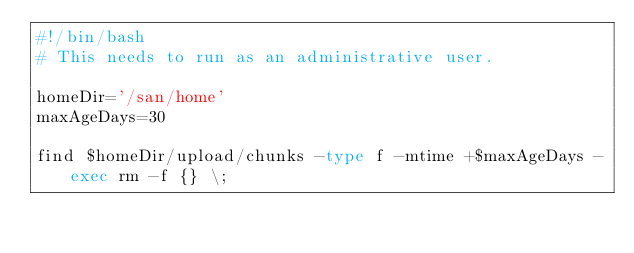Convert code to text. <code><loc_0><loc_0><loc_500><loc_500><_Bash_>#!/bin/bash
# This needs to run as an administrative user.

homeDir='/san/home'
maxAgeDays=30

find $homeDir/upload/chunks -type f -mtime +$maxAgeDays -exec rm -f {} \;
</code> 